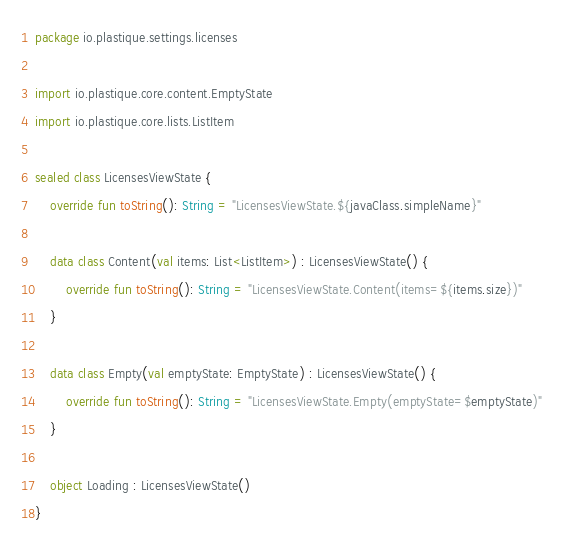<code> <loc_0><loc_0><loc_500><loc_500><_Kotlin_>package io.plastique.settings.licenses

import io.plastique.core.content.EmptyState
import io.plastique.core.lists.ListItem

sealed class LicensesViewState {
    override fun toString(): String = "LicensesViewState.${javaClass.simpleName}"

    data class Content(val items: List<ListItem>) : LicensesViewState() {
        override fun toString(): String = "LicensesViewState.Content(items=${items.size})"
    }

    data class Empty(val emptyState: EmptyState) : LicensesViewState() {
        override fun toString(): String = "LicensesViewState.Empty(emptyState=$emptyState)"
    }

    object Loading : LicensesViewState()
}
</code> 